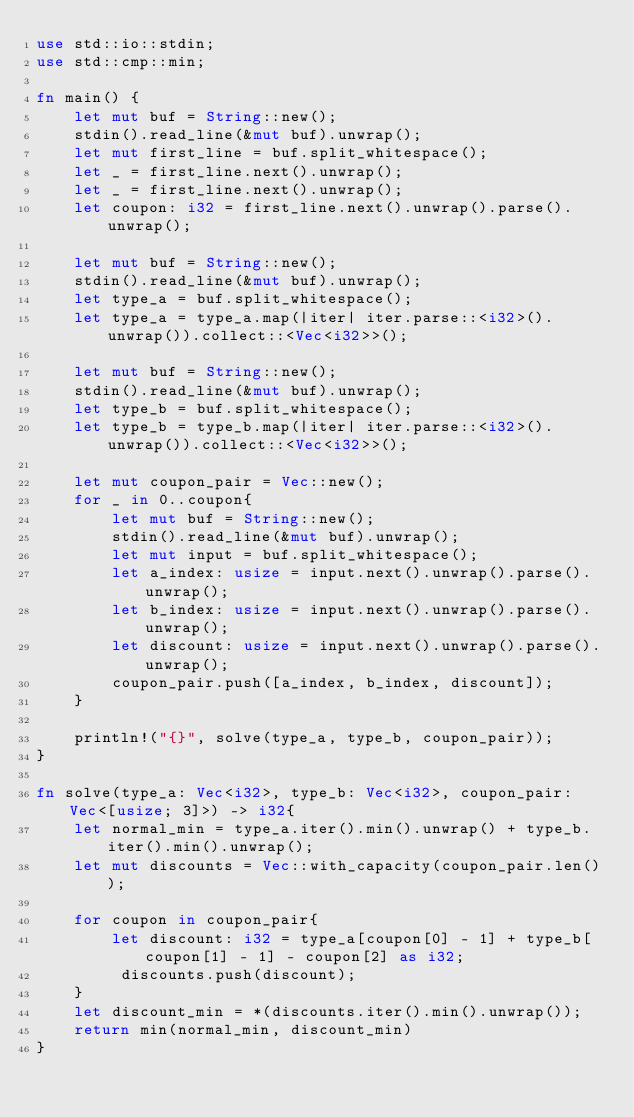Convert code to text. <code><loc_0><loc_0><loc_500><loc_500><_Rust_>use std::io::stdin;
use std::cmp::min;

fn main() {
    let mut buf = String::new();
    stdin().read_line(&mut buf).unwrap();
    let mut first_line = buf.split_whitespace();
    let _ = first_line.next().unwrap();
    let _ = first_line.next().unwrap();
    let coupon: i32 = first_line.next().unwrap().parse().unwrap();

    let mut buf = String::new();
    stdin().read_line(&mut buf).unwrap();
    let type_a = buf.split_whitespace();
    let type_a = type_a.map(|iter| iter.parse::<i32>().unwrap()).collect::<Vec<i32>>();

    let mut buf = String::new();
    stdin().read_line(&mut buf).unwrap();
    let type_b = buf.split_whitespace();
    let type_b = type_b.map(|iter| iter.parse::<i32>().unwrap()).collect::<Vec<i32>>();

    let mut coupon_pair = Vec::new();
    for _ in 0..coupon{
        let mut buf = String::new();
        stdin().read_line(&mut buf).unwrap();
        let mut input = buf.split_whitespace();
        let a_index: usize = input.next().unwrap().parse().unwrap();
        let b_index: usize = input.next().unwrap().parse().unwrap();
        let discount: usize = input.next().unwrap().parse().unwrap();
        coupon_pair.push([a_index, b_index, discount]);
    }

    println!("{}", solve(type_a, type_b, coupon_pair));
}

fn solve(type_a: Vec<i32>, type_b: Vec<i32>, coupon_pair: Vec<[usize; 3]>) -> i32{
    let normal_min = type_a.iter().min().unwrap() + type_b.iter().min().unwrap();
    let mut discounts = Vec::with_capacity(coupon_pair.len());
    
    for coupon in coupon_pair{
        let discount: i32 = type_a[coupon[0] - 1] + type_b[coupon[1] - 1] - coupon[2] as i32;
         discounts.push(discount);
    }
    let discount_min = *(discounts.iter().min().unwrap());
    return min(normal_min, discount_min)
}</code> 